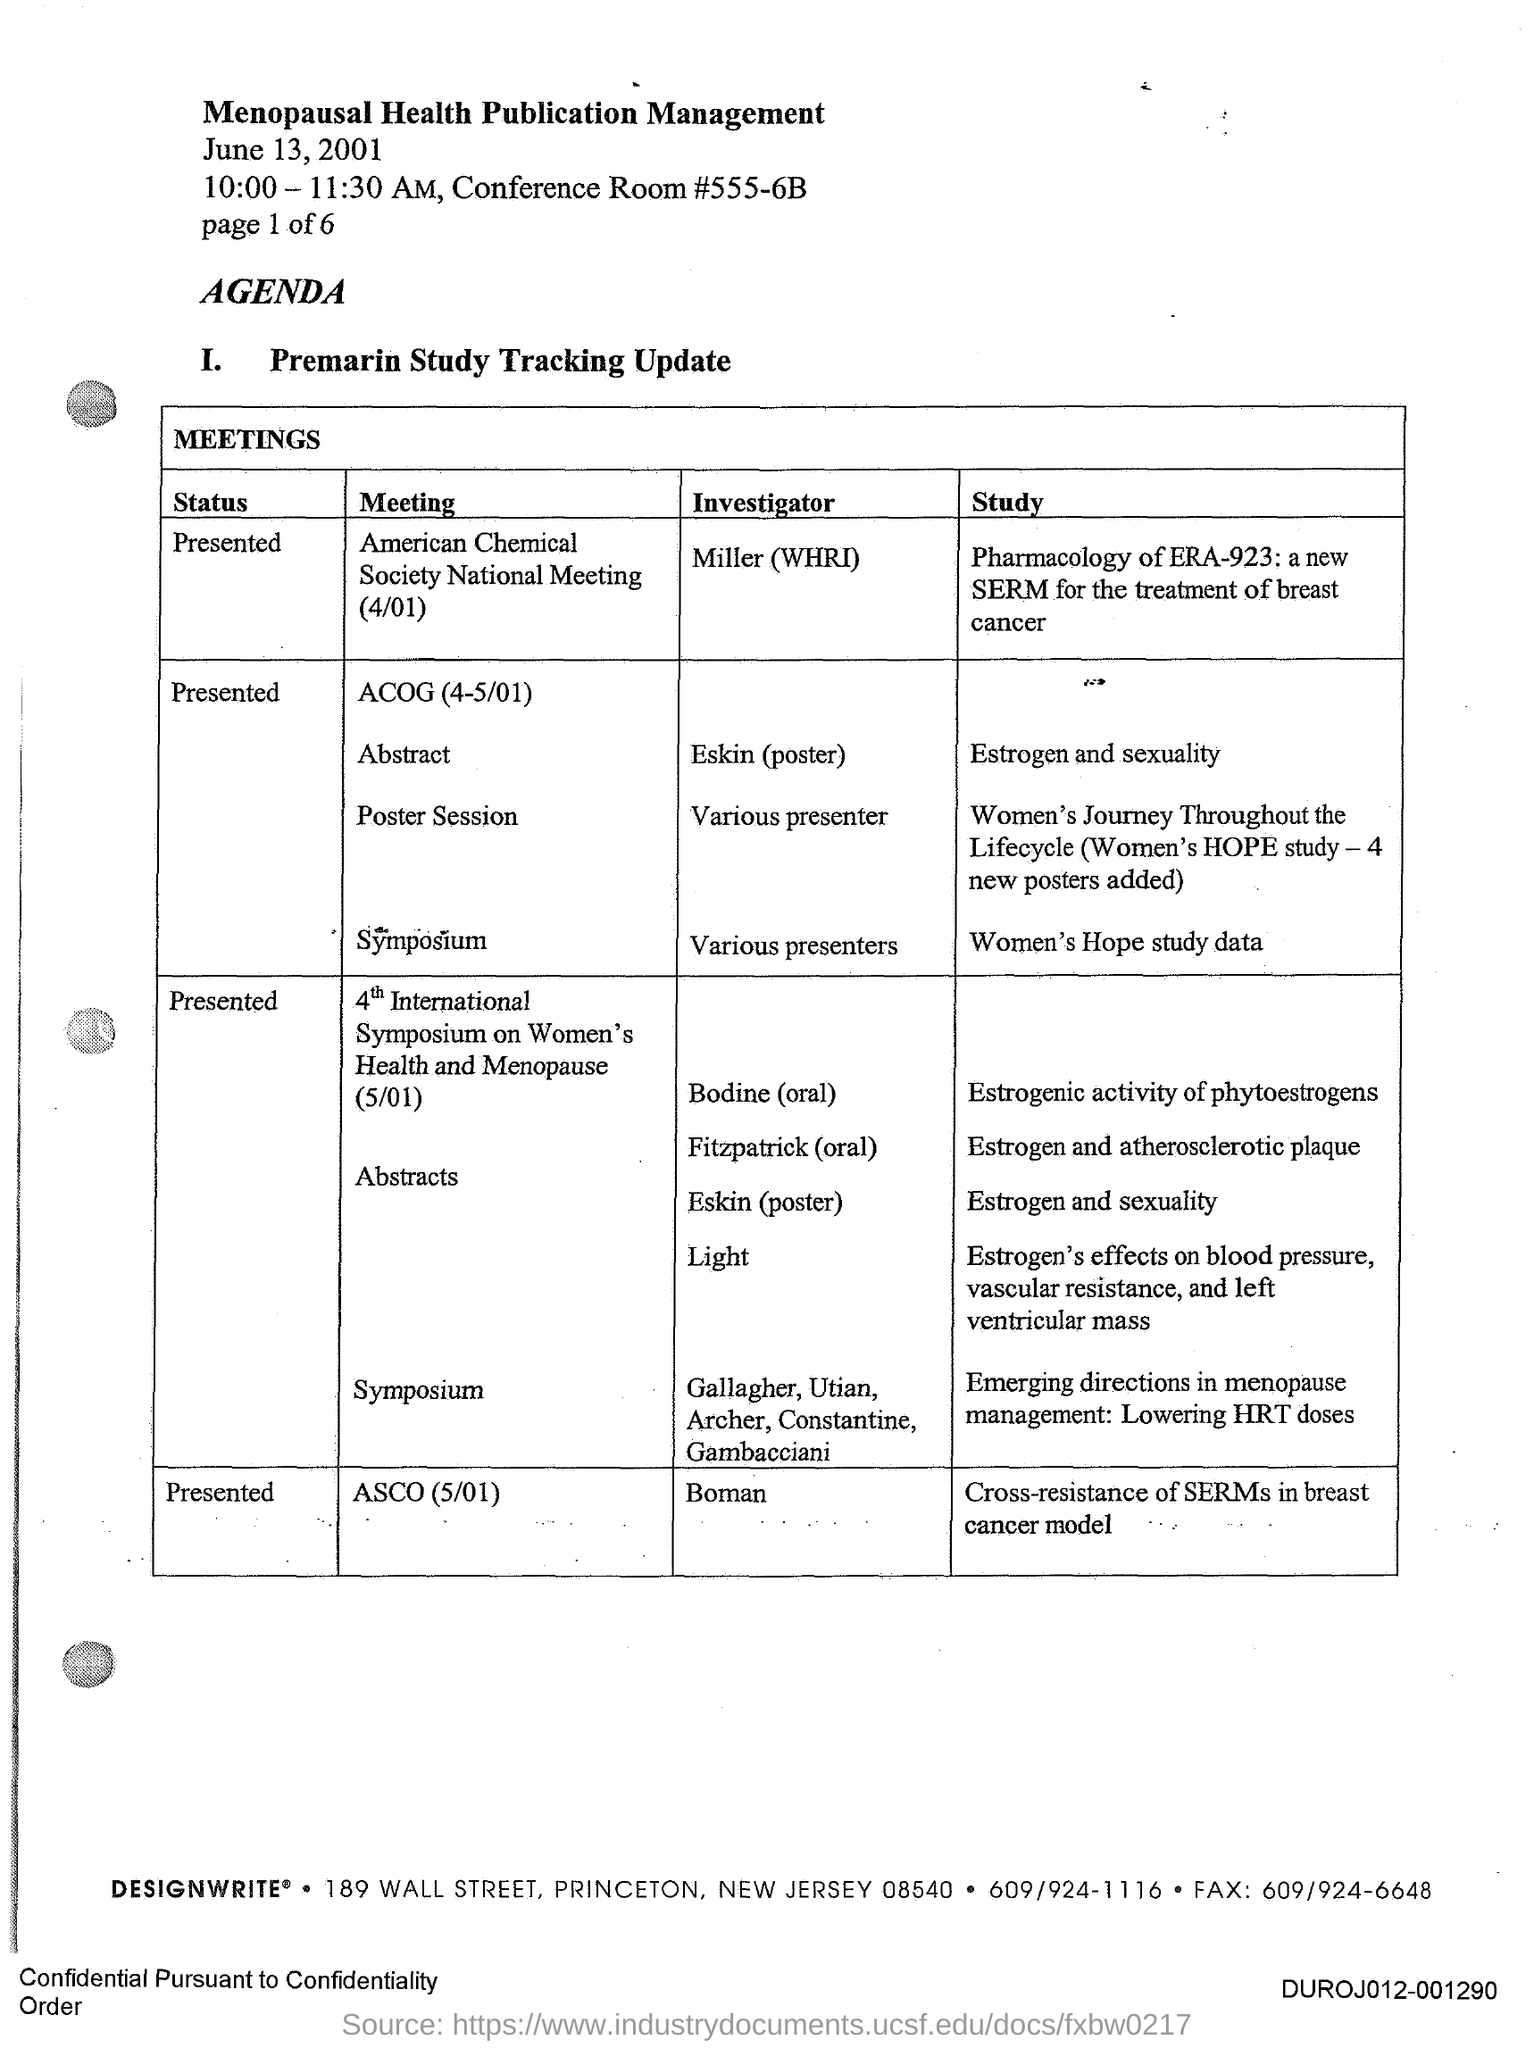Highlight a few significant elements in this photo. The investigator of the meeting is ASCO (May 1, 2025) and their name is Boman. The title of the document is "Menopausal Health Publication Management. The investigator of the meeting "American Chemical Society National Meeting(4/01)" is Miller of the WHRI. The 4th International Symposium on Women's Health and Menopause has been presented. 